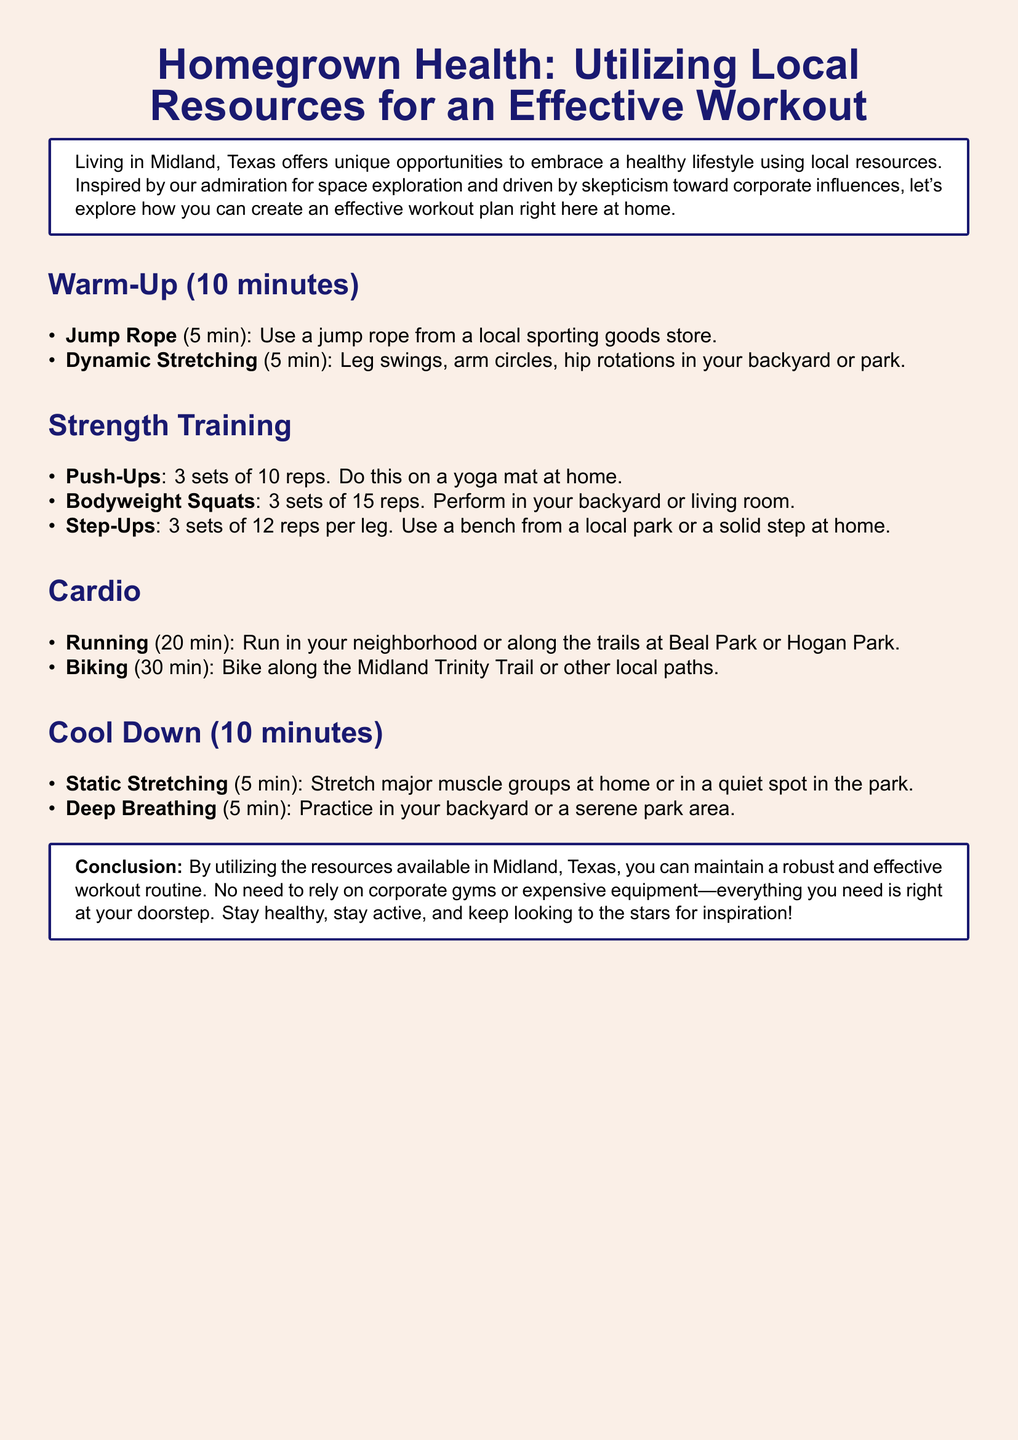What is the warm-up duration? The warm-up section in the document states that it lasts for 10 minutes.
Answer: 10 minutes How many sets of push-ups are recommended? The strength training section indicates 3 sets of 10 reps for push-ups.
Answer: 3 sets What type of cardio exercise is included? The cardio section lists running and biking as the two activities.
Answer: Running and biking How long should you run according to the plan? The document specifies a duration of 20 minutes for running.
Answer: 20 minutes What is the final activity in the cool down? The cool down section mentions deep breathing as the last activity.
Answer: Deep breathing Where can you perform dynamic stretching? The document suggests doing dynamic stretching in your backyard or park.
Answer: Backyard or park What equipment is suggested for step-ups? The plan recommends using a bench from a park or a solid step at home for step-ups.
Answer: Bench or solid step How many bodyweight squats are suggested? The strength training section states 3 sets of 15 reps for bodyweight squats.
Answer: 3 sets of 15 reps 